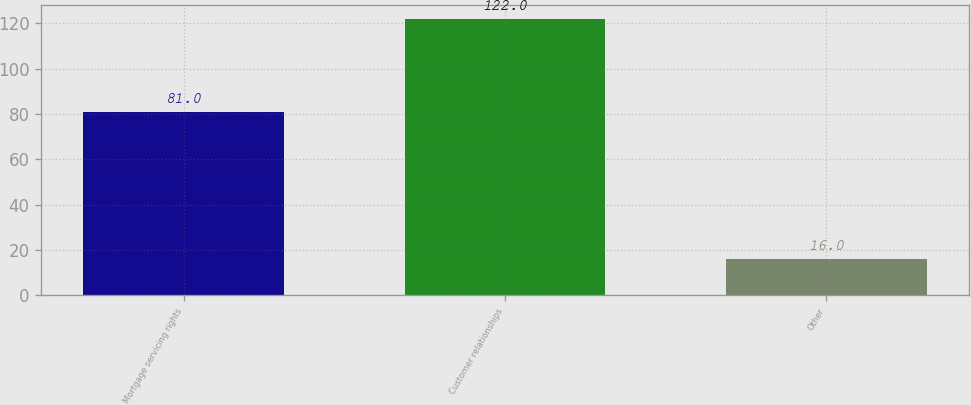Convert chart. <chart><loc_0><loc_0><loc_500><loc_500><bar_chart><fcel>Mortgage servicing rights<fcel>Customer relationships<fcel>Other<nl><fcel>81<fcel>122<fcel>16<nl></chart> 